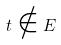<formula> <loc_0><loc_0><loc_500><loc_500>t \notin E</formula> 